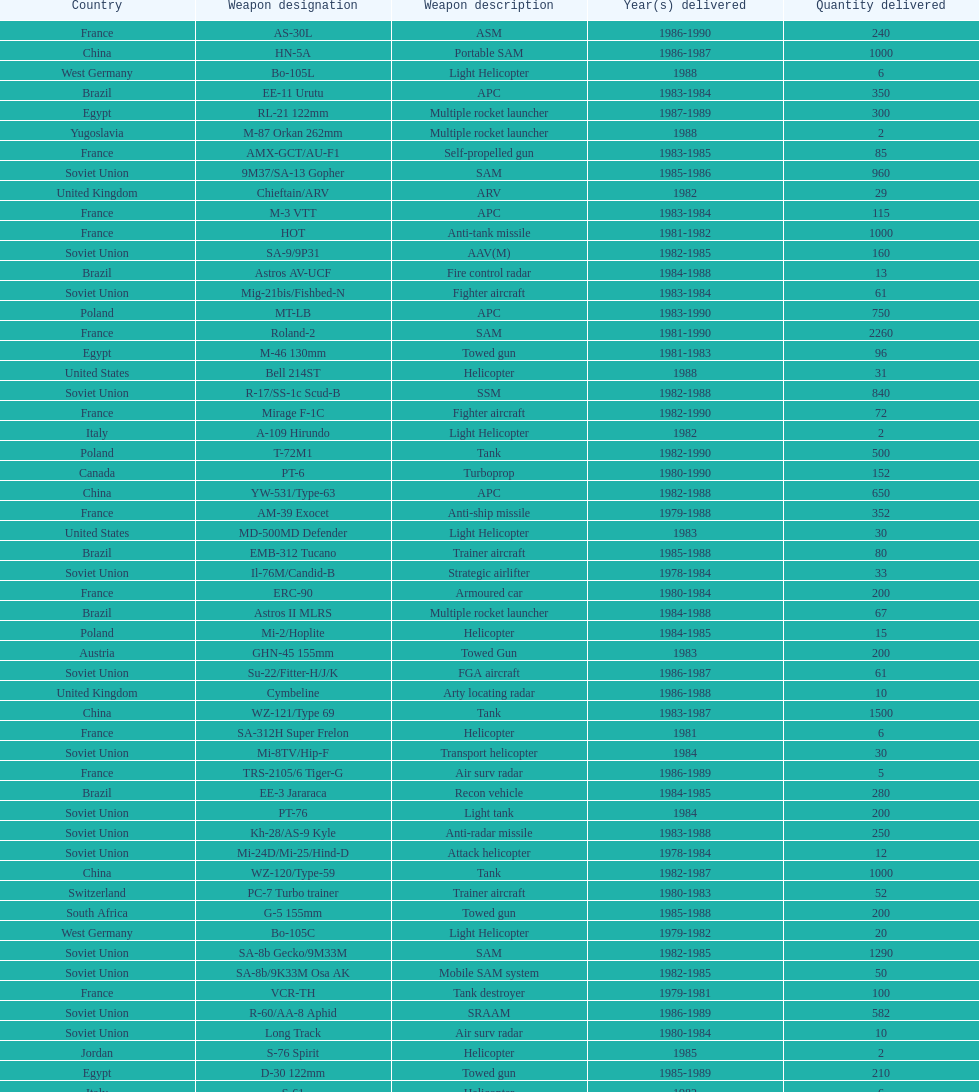Would you be able to parse every entry in this table? {'header': ['Country', 'Weapon designation', 'Weapon description', 'Year(s) delivered', 'Quantity delivered'], 'rows': [['France', 'AS-30L', 'ASM', '1986-1990', '240'], ['China', 'HN-5A', 'Portable SAM', '1986-1987', '1000'], ['West Germany', 'Bo-105L', 'Light Helicopter', '1988', '6'], ['Brazil', 'EE-11 Urutu', 'APC', '1983-1984', '350'], ['Egypt', 'RL-21 122mm', 'Multiple rocket launcher', '1987-1989', '300'], ['Yugoslavia', 'M-87 Orkan 262mm', 'Multiple rocket launcher', '1988', '2'], ['France', 'AMX-GCT/AU-F1', 'Self-propelled gun', '1983-1985', '85'], ['Soviet Union', '9M37/SA-13 Gopher', 'SAM', '1985-1986', '960'], ['United Kingdom', 'Chieftain/ARV', 'ARV', '1982', '29'], ['France', 'M-3 VTT', 'APC', '1983-1984', '115'], ['France', 'HOT', 'Anti-tank missile', '1981-1982', '1000'], ['Soviet Union', 'SA-9/9P31', 'AAV(M)', '1982-1985', '160'], ['Brazil', 'Astros AV-UCF', 'Fire control radar', '1984-1988', '13'], ['Soviet Union', 'Mig-21bis/Fishbed-N', 'Fighter aircraft', '1983-1984', '61'], ['Poland', 'MT-LB', 'APC', '1983-1990', '750'], ['France', 'Roland-2', 'SAM', '1981-1990', '2260'], ['Egypt', 'M-46 130mm', 'Towed gun', '1981-1983', '96'], ['United States', 'Bell 214ST', 'Helicopter', '1988', '31'], ['Soviet Union', 'R-17/SS-1c Scud-B', 'SSM', '1982-1988', '840'], ['France', 'Mirage F-1C', 'Fighter aircraft', '1982-1990', '72'], ['Italy', 'A-109 Hirundo', 'Light Helicopter', '1982', '2'], ['Poland', 'T-72M1', 'Tank', '1982-1990', '500'], ['Canada', 'PT-6', 'Turboprop', '1980-1990', '152'], ['China', 'YW-531/Type-63', 'APC', '1982-1988', '650'], ['France', 'AM-39 Exocet', 'Anti-ship missile', '1979-1988', '352'], ['United States', 'MD-500MD Defender', 'Light Helicopter', '1983', '30'], ['Brazil', 'EMB-312 Tucano', 'Trainer aircraft', '1985-1988', '80'], ['Soviet Union', 'Il-76M/Candid-B', 'Strategic airlifter', '1978-1984', '33'], ['France', 'ERC-90', 'Armoured car', '1980-1984', '200'], ['Brazil', 'Astros II MLRS', 'Multiple rocket launcher', '1984-1988', '67'], ['Poland', 'Mi-2/Hoplite', 'Helicopter', '1984-1985', '15'], ['Austria', 'GHN-45 155mm', 'Towed Gun', '1983', '200'], ['Soviet Union', 'Su-22/Fitter-H/J/K', 'FGA aircraft', '1986-1987', '61'], ['United Kingdom', 'Cymbeline', 'Arty locating radar', '1986-1988', '10'], ['China', 'WZ-121/Type 69', 'Tank', '1983-1987', '1500'], ['France', 'SA-312H Super Frelon', 'Helicopter', '1981', '6'], ['Soviet Union', 'Mi-8TV/Hip-F', 'Transport helicopter', '1984', '30'], ['France', 'TRS-2105/6 Tiger-G', 'Air surv radar', '1986-1989', '5'], ['Brazil', 'EE-3 Jararaca', 'Recon vehicle', '1984-1985', '280'], ['Soviet Union', 'PT-76', 'Light tank', '1984', '200'], ['Soviet Union', 'Kh-28/AS-9 Kyle', 'Anti-radar missile', '1983-1988', '250'], ['Soviet Union', 'Mi-24D/Mi-25/Hind-D', 'Attack helicopter', '1978-1984', '12'], ['China', 'WZ-120/Type-59', 'Tank', '1982-1987', '1000'], ['Switzerland', 'PC-7 Turbo trainer', 'Trainer aircraft', '1980-1983', '52'], ['South Africa', 'G-5 155mm', 'Towed gun', '1985-1988', '200'], ['West Germany', 'Bo-105C', 'Light Helicopter', '1979-1982', '20'], ['Soviet Union', 'SA-8b Gecko/9M33M', 'SAM', '1982-1985', '1290'], ['Soviet Union', 'SA-8b/9K33M Osa AK', 'Mobile SAM system', '1982-1985', '50'], ['France', 'VCR-TH', 'Tank destroyer', '1979-1981', '100'], ['Soviet Union', 'R-60/AA-8 Aphid', 'SRAAM', '1986-1989', '582'], ['Soviet Union', 'Long Track', 'Air surv radar', '1980-1984', '10'], ['Jordan', 'S-76 Spirit', 'Helicopter', '1985', '2'], ['Egypt', 'D-30 122mm', 'Towed gun', '1985-1989', '210'], ['Italy', 'S-61', 'Helicopter', '1982', '6'], ['Soviet Union', '2S4 240mm', 'Self-propelled mortar', '1983', '10'], ['France', 'R-550 Magic-1', 'SRAAM', '1981-1985', '534'], ['Italy', 'Stromboli class', 'Support ship', '1981', '1'], ['China', 'F-7A', 'Fighter aircraft', '1983-1987', '80'], ['France', 'ARMAT', 'Anti-radar missile', '1986-1990', '450'], ['Switzerland', 'PC-9', 'Trainer aircraft', '1987-1990', '20'], ['France', 'AMX-10P', 'Infantry fighting vehicle', '1981-1982', '100'], ['Soviet Union', '9M111/AT-4 Spigot', 'Anti-tank missile', '1986-1989', '3000'], ['France', 'AMX-30D', 'ARV', '1981', '5'], ['Czechoslovakia', 'OT-64C', 'APC', '1981', '200'], ['France', 'Rasit', 'Ground surv radar', '1985', '2'], ['Soviet Union', 'Mi-8/Mi-17/Hip-H', 'Transport helicopter', '1986-1987', '37'], ['Soviet Union', 'KSR-5/AS-6 Kingfish', 'Anti-ship missile', '1984', '36'], ['Switzerland', 'Roland', 'APC/IFV', '1981', '100'], ['China', 'F-6', 'Fighter aircraft', '1982-1983', '40'], ['Egypt', 'Walid', 'APC', '1980', '100'], ['Czechoslovakia', 'BMP-1', 'Infantry fighting vehicle', '1981-1987', '750'], ['Soviet Union', 'Mig-29/Fulcrum-A', 'Fighter aircraft', '1986-1989', '41'], ['China', 'Type-63 107mm', 'Multiple rocket launcher', '1984-1988', '100'], ['Soviet Union', 'M-46 130mm', 'Towed Gun', '1982-1987', '576'], ['Soviet Union', 'M-240 240mm', 'Mortar', '1981', '25'], ['Soviet Union', 'Thin Skin', 'Air surv radar', '1980-1984', '5'], ['Czechoslovakia', 'BMP-2', 'Infantry fighting vehicle', '1987-1989', '250'], ['Soviet Union', 'Mig-23BN/Flogger-H', 'FGA aircraft', '1984-1985', '50'], ['Czechoslovakia', 'L-39Z Albatross', 'Trainer/combat aircraft', '1976-1985', '59'], ['France', 'SA-342K/L Gazelle', 'Light helicopter', '1980-1988', '38'], ['Soviet Union', 'Strela-3/SA-14 Gremlin', 'Portable SAM', '1987-1988', '500'], ['China', 'HY-2/SY1A/CSS-N-2', 'Anti-ship missile', '1987-1988', '200'], ['United States', 'MD-530F', 'Light Helicopter', '1986', '26'], ['Soviet Union', '2S3 152mm', 'Self-propelled gun', '1980-1989', '150'], ['France', 'Mirage F-1E', 'FGA aircraft', '1980-1982', '36'], ['China', 'Type-83 152mm', 'Towed gun', '1988-1989', '50'], ['China', 'W-653/Type-653', 'ARV', '1986-1987', '25'], ['Soviet Union', 'R-13S/AA2S Atoll', 'SRAAM', '1984-1987', '1080'], ['France', 'TRS-2230/15 Tiger', 'Air surv radar', '1984-1985', '6'], ['Egypt', 'T-55', 'Tank', '1981-1983', '300'], ['Soviet Union', 'BMD-1', 'IFV', '1981', '10'], ['Soviet Union', 'R-27/AA-10 Alamo', 'BVRAAM', '1986-1989', '246'], ['United States', 'Hughes-300/TH-55', 'Light Helicopter', '1983', '30'], ['China', 'Xian H-6', 'Bomber aircraft', '1988', '4'], ['France', 'SA-330 Puma', 'Helicopter', '1980-1981', '20'], ['France', 'Volex', 'Air surv radar', '1981-1983', '5'], ['France', 'Roland', 'Mobile SAM system', '1982-1985', '113'], ['Soviet Union', 'Mig-25RB/Foxbat-B', 'Recon aircraft', '1982', '8'], ['Soviet Union', '2S1 122mm', 'Self-Propelled Howitzer', '1980-1989', '150'], ['Soviet Union', 'D-30 122mm', 'Towed gun', '1982-1988', '576'], ['East Germany', 'T-55', 'Tank', '1981', '50'], ['Soviet Union', 'BM-21 Grad 122mm', 'Multiple rocket launcher', '1983-1988', '560'], ['Denmark', 'Al Zahraa', 'Landing ship', '1983', '3'], ['Soviet Union', 'SA-9 Gaskin/9M31', 'SAM', '1982-1985', '1920'], ['Soviet Union', '2A36 152mm', 'Towed gun', '1986-1988', '180'], ['Soviet Union', 'R-40R/AA-6 Acrid', 'BVRAAM', '1980-1985', '660'], ['Romania', 'T-55', 'Tank', '1982-1984', '150'], ['Soviet Union', 'Mig-25P/Foxbat-A', 'Interceptor aircraft', '1980-1985', '55'], ['France', 'Super 530F', 'BVRAAM', '1981-1985', '300'], ['France', 'Super Etendard', 'FGA aircraft', '1983', '5'], ['Czechoslovakia', 'T-55', 'Tank', '1982-1985', '400'], ['Soviet Union', '9K35 Strela-10/SA-13', 'AAV(M)', '1985', '30'], ['China', 'CEIEC-408C', 'Air surv radar', '1986-1988', '5'], ['West Germany', 'BK-117', 'Helicopter', '1984-1989', '22'], ['Brazil', 'EE-9 Cascavel', 'Armoured car', '1980-1989', '1026'], ['France', 'TRS-2100 Tiger', 'Air surv radar', '1988', '1'], ['Poland', 'T-55', 'Tank', '1981-1982', '400'], ['Soviet Union', '9P117/SS-1 Scud TEL', 'SSM launcher', '1983-1984', '10'], ['Hungary', 'PSZH-D-994', 'APC', '1981', '300'], ['Soviet Union', 'Su-25/Frogfoot-A', 'Ground attack aircraft', '1986-1987', '84']]} Which was the first country to sell weapons to iraq? Czechoslovakia. 